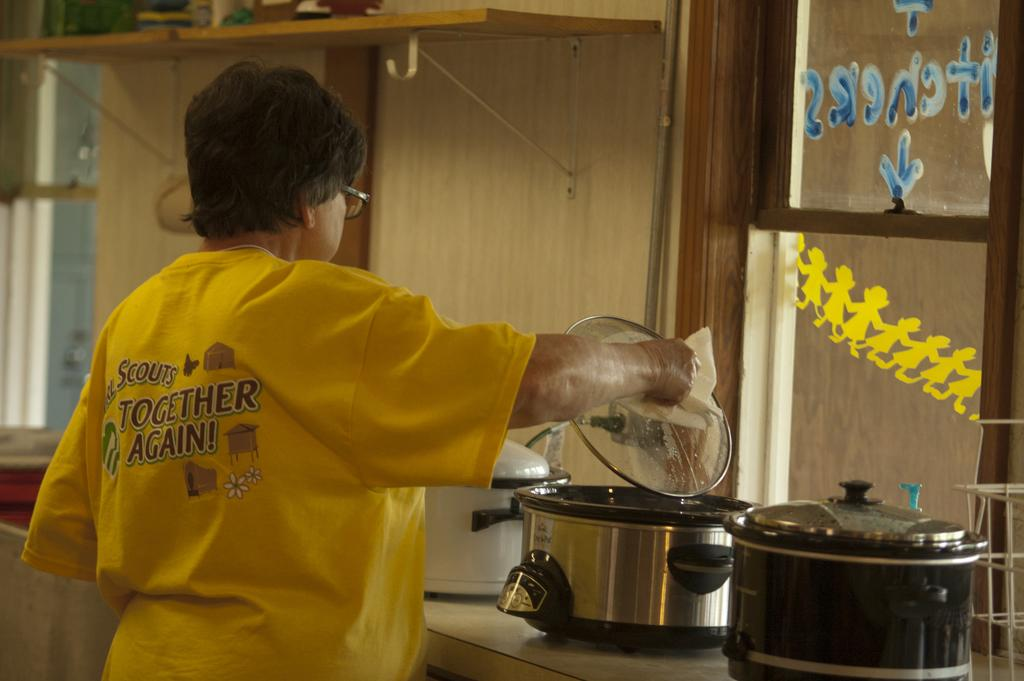<image>
Relay a brief, clear account of the picture shown. A person in a yellow shirt with Together Again using a crock pot. 